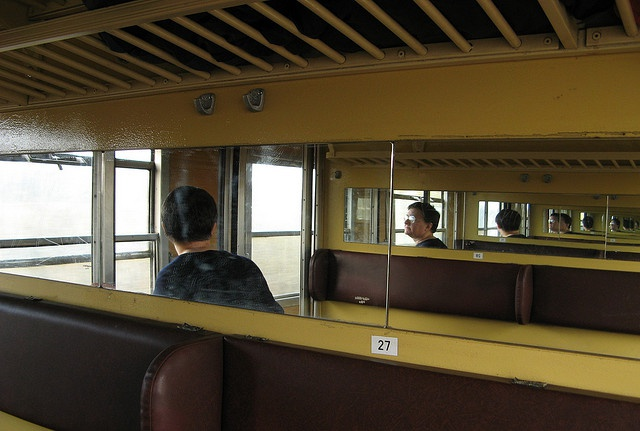Describe the objects in this image and their specific colors. I can see people in black, maroon, gray, and purple tones, people in black, maroon, and gray tones, people in black, darkgreen, maroon, and gray tones, people in black, maroon, and gray tones, and people in black, gray, and tan tones in this image. 